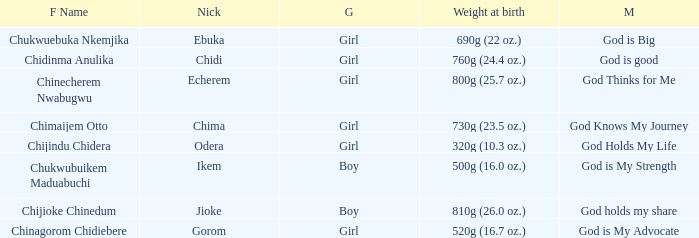What is the nickname of the baby with the birth weight of 730g (23.5 oz.)? Chima. 